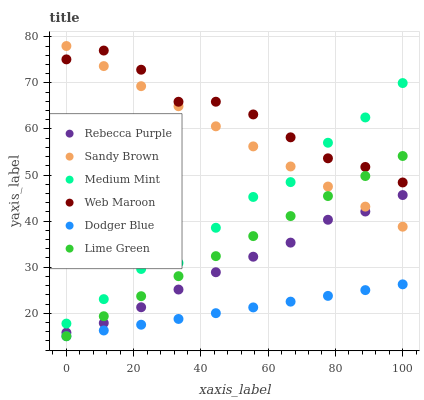Does Dodger Blue have the minimum area under the curve?
Answer yes or no. Yes. Does Web Maroon have the maximum area under the curve?
Answer yes or no. Yes. Does Lime Green have the minimum area under the curve?
Answer yes or no. No. Does Lime Green have the maximum area under the curve?
Answer yes or no. No. Is Dodger Blue the smoothest?
Answer yes or no. Yes. Is Medium Mint the roughest?
Answer yes or no. Yes. Is Lime Green the smoothest?
Answer yes or no. No. Is Lime Green the roughest?
Answer yes or no. No. Does Lime Green have the lowest value?
Answer yes or no. Yes. Does Web Maroon have the lowest value?
Answer yes or no. No. Does Sandy Brown have the highest value?
Answer yes or no. Yes. Does Lime Green have the highest value?
Answer yes or no. No. Is Lime Green less than Medium Mint?
Answer yes or no. Yes. Is Medium Mint greater than Lime Green?
Answer yes or no. Yes. Does Sandy Brown intersect Medium Mint?
Answer yes or no. Yes. Is Sandy Brown less than Medium Mint?
Answer yes or no. No. Is Sandy Brown greater than Medium Mint?
Answer yes or no. No. Does Lime Green intersect Medium Mint?
Answer yes or no. No. 